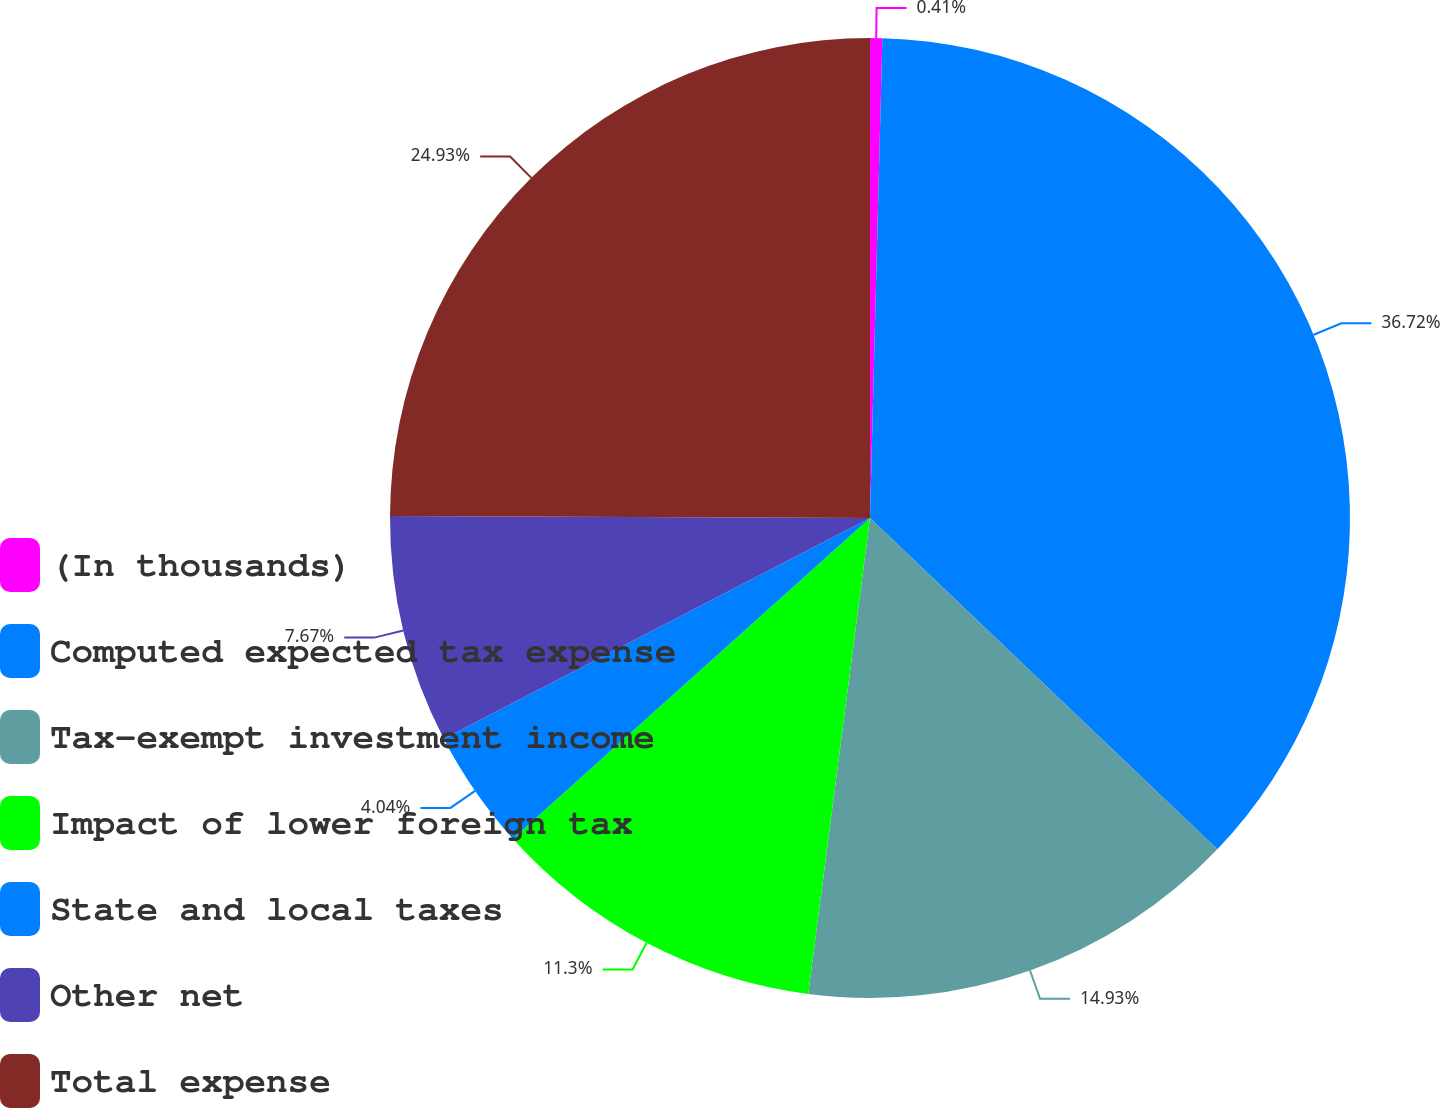Convert chart to OTSL. <chart><loc_0><loc_0><loc_500><loc_500><pie_chart><fcel>(In thousands)<fcel>Computed expected tax expense<fcel>Tax-exempt investment income<fcel>Impact of lower foreign tax<fcel>State and local taxes<fcel>Other net<fcel>Total expense<nl><fcel>0.41%<fcel>36.71%<fcel>14.93%<fcel>11.3%<fcel>4.04%<fcel>7.67%<fcel>24.93%<nl></chart> 